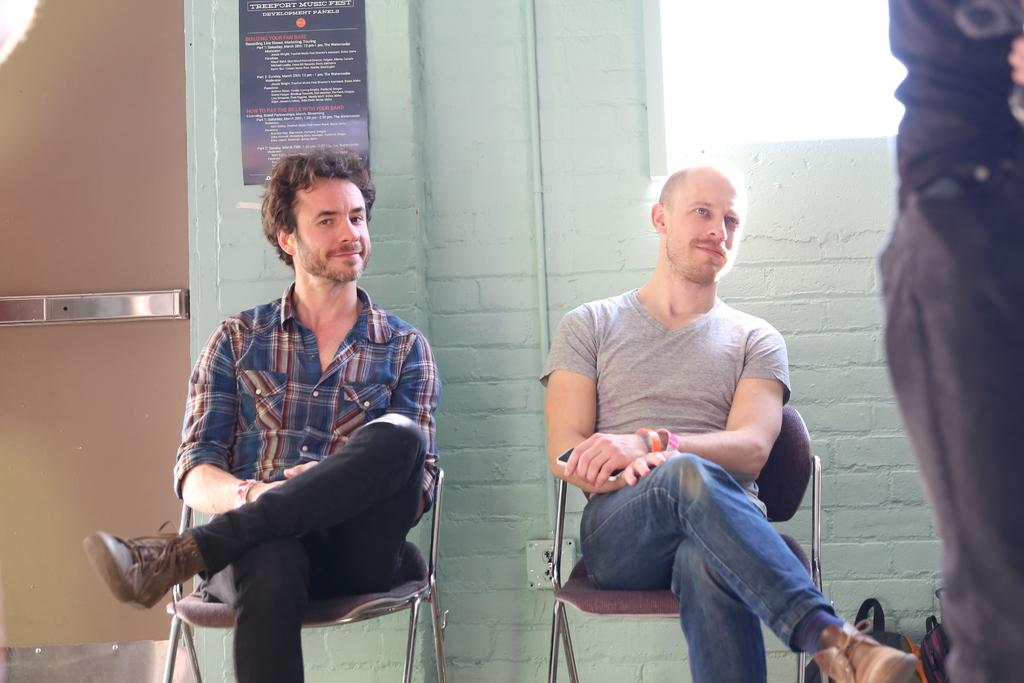How many people are sitting in the image? There are two persons sitting on chairs in the image. What is the position of the person who is not sitting? There is one person standing on the right side of the image. What can be seen in the background of the image? There is a wall and a door in the background of the image, along with additional objects. What type of seed is being planted in the image? There is no seed or planting activity depicted in the image. What date is marked on the calendar in the image? There is no calendar present in the image. 